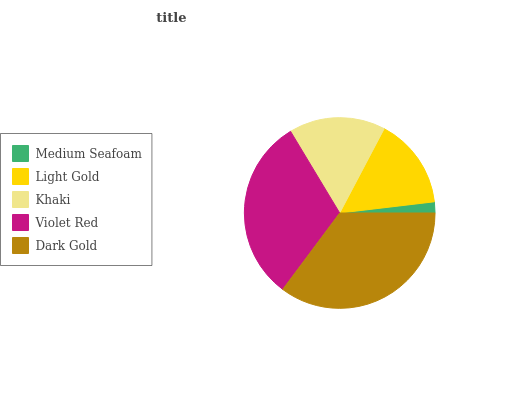Is Medium Seafoam the minimum?
Answer yes or no. Yes. Is Dark Gold the maximum?
Answer yes or no. Yes. Is Light Gold the minimum?
Answer yes or no. No. Is Light Gold the maximum?
Answer yes or no. No. Is Light Gold greater than Medium Seafoam?
Answer yes or no. Yes. Is Medium Seafoam less than Light Gold?
Answer yes or no. Yes. Is Medium Seafoam greater than Light Gold?
Answer yes or no. No. Is Light Gold less than Medium Seafoam?
Answer yes or no. No. Is Khaki the high median?
Answer yes or no. Yes. Is Khaki the low median?
Answer yes or no. Yes. Is Medium Seafoam the high median?
Answer yes or no. No. Is Light Gold the low median?
Answer yes or no. No. 